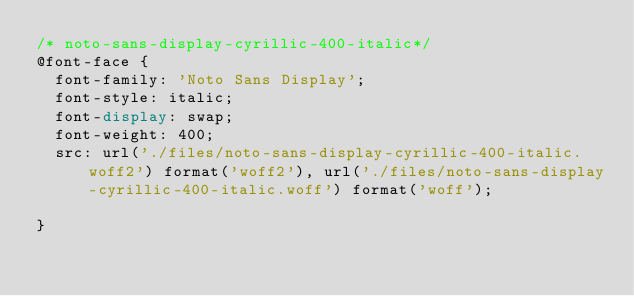<code> <loc_0><loc_0><loc_500><loc_500><_CSS_>/* noto-sans-display-cyrillic-400-italic*/
@font-face {
  font-family: 'Noto Sans Display';
  font-style: italic;
  font-display: swap;
  font-weight: 400;
  src: url('./files/noto-sans-display-cyrillic-400-italic.woff2') format('woff2'), url('./files/noto-sans-display-cyrillic-400-italic.woff') format('woff');
  
}
</code> 